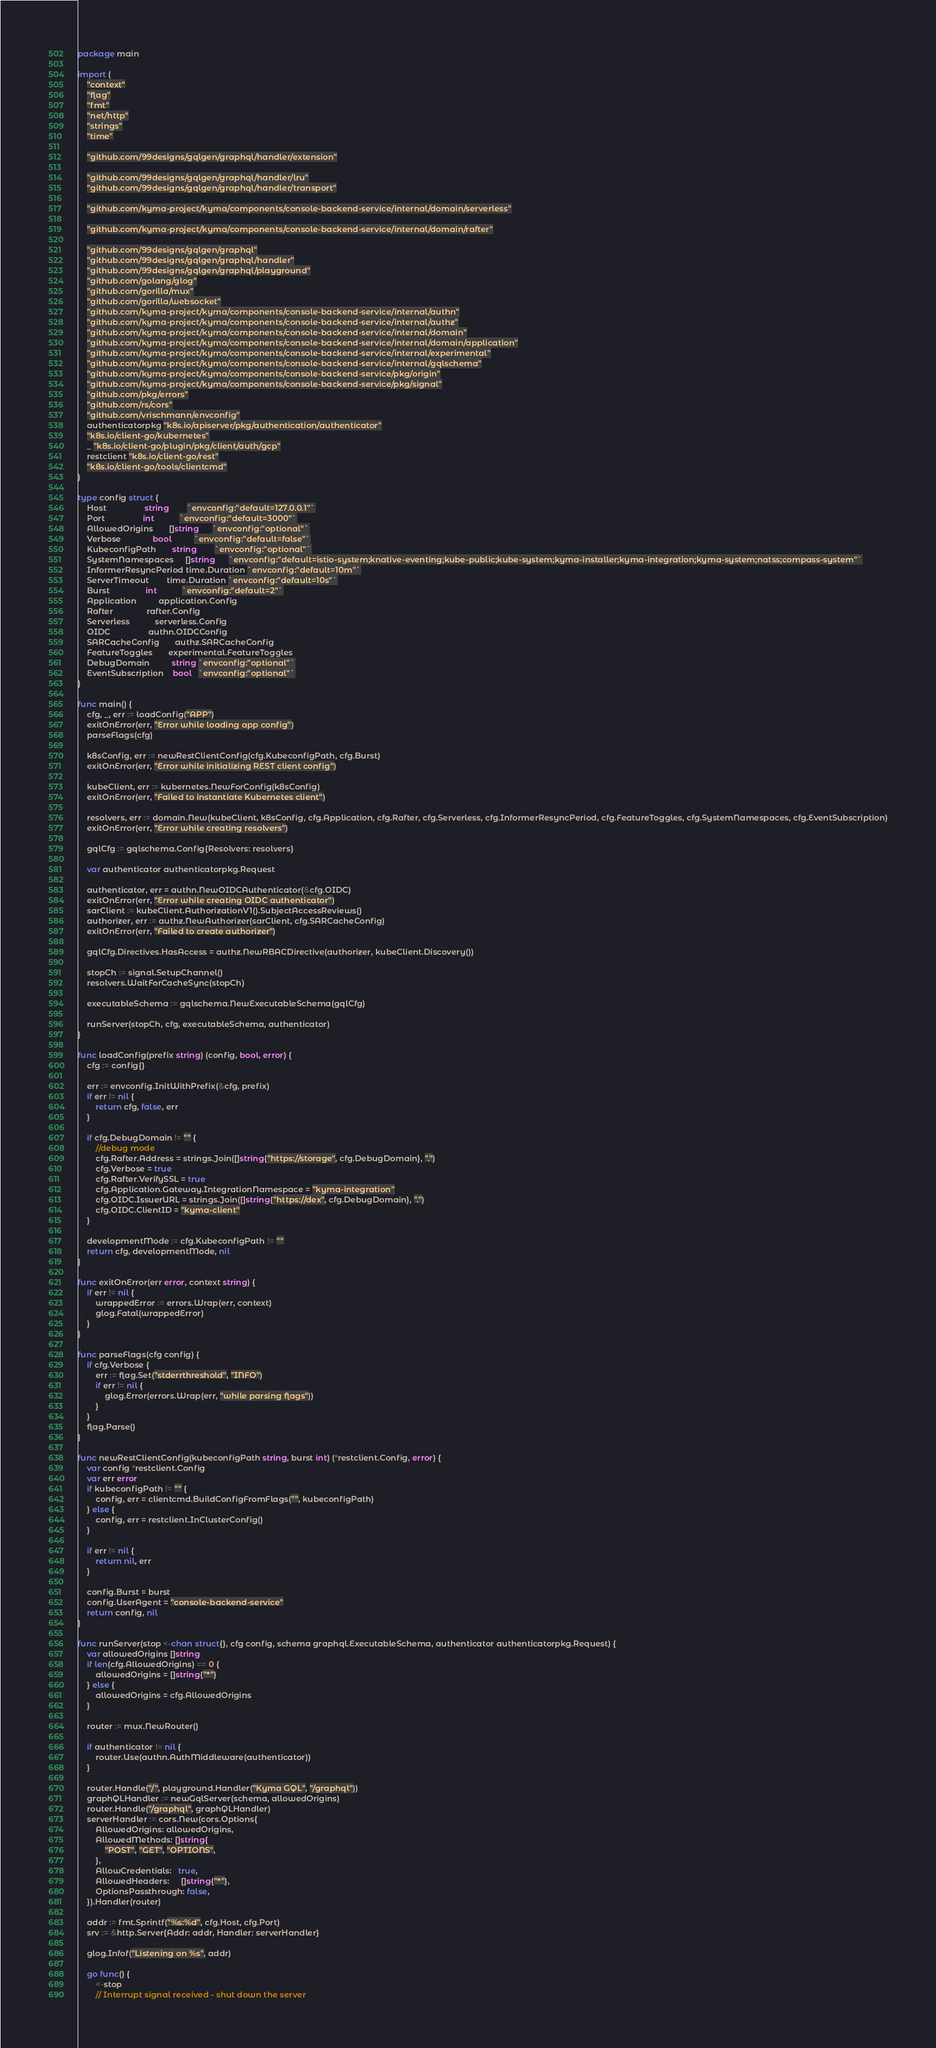Convert code to text. <code><loc_0><loc_0><loc_500><loc_500><_Go_>package main

import (
	"context"
	"flag"
	"fmt"
	"net/http"
	"strings"
	"time"

	"github.com/99designs/gqlgen/graphql/handler/extension"

	"github.com/99designs/gqlgen/graphql/handler/lru"
	"github.com/99designs/gqlgen/graphql/handler/transport"

	"github.com/kyma-project/kyma/components/console-backend-service/internal/domain/serverless"

	"github.com/kyma-project/kyma/components/console-backend-service/internal/domain/rafter"

	"github.com/99designs/gqlgen/graphql"
	"github.com/99designs/gqlgen/graphql/handler"
	"github.com/99designs/gqlgen/graphql/playground"
	"github.com/golang/glog"
	"github.com/gorilla/mux"
	"github.com/gorilla/websocket"
	"github.com/kyma-project/kyma/components/console-backend-service/internal/authn"
	"github.com/kyma-project/kyma/components/console-backend-service/internal/authz"
	"github.com/kyma-project/kyma/components/console-backend-service/internal/domain"
	"github.com/kyma-project/kyma/components/console-backend-service/internal/domain/application"
	"github.com/kyma-project/kyma/components/console-backend-service/internal/experimental"
	"github.com/kyma-project/kyma/components/console-backend-service/internal/gqlschema"
	"github.com/kyma-project/kyma/components/console-backend-service/pkg/origin"
	"github.com/kyma-project/kyma/components/console-backend-service/pkg/signal"
	"github.com/pkg/errors"
	"github.com/rs/cors"
	"github.com/vrischmann/envconfig"
	authenticatorpkg "k8s.io/apiserver/pkg/authentication/authenticator"
	"k8s.io/client-go/kubernetes"
	_ "k8s.io/client-go/plugin/pkg/client/auth/gcp"
	restclient "k8s.io/client-go/rest"
	"k8s.io/client-go/tools/clientcmd"
)

type config struct {
	Host                 string        `envconfig:"default=127.0.0.1"`
	Port                 int           `envconfig:"default=3000"`
	AllowedOrigins       []string      `envconfig:"optional"`
	Verbose              bool          `envconfig:"default=false"`
	KubeconfigPath       string        `envconfig:"optional"`
	SystemNamespaces     []string      `envconfig:"default=istio-system;knative-eventing;kube-public;kube-system;kyma-installer;kyma-integration;kyma-system;natss;compass-system"`
	InformerResyncPeriod time.Duration `envconfig:"default=10m"`
	ServerTimeout        time.Duration `envconfig:"default=10s"`
	Burst                int           `envconfig:"default=2"`
	Application          application.Config
	Rafter               rafter.Config
	Serverless           serverless.Config
	OIDC                 authn.OIDCConfig
	SARCacheConfig       authz.SARCacheConfig
	FeatureToggles       experimental.FeatureToggles
	DebugDomain          string `envconfig:"optional"`
	EventSubscription    bool   `envconfig:"optional"`
}

func main() {
	cfg, _, err := loadConfig("APP")
	exitOnError(err, "Error while loading app config")
	parseFlags(cfg)

	k8sConfig, err := newRestClientConfig(cfg.KubeconfigPath, cfg.Burst)
	exitOnError(err, "Error while initializing REST client config")

	kubeClient, err := kubernetes.NewForConfig(k8sConfig)
	exitOnError(err, "Failed to instantiate Kubernetes client")

	resolvers, err := domain.New(kubeClient, k8sConfig, cfg.Application, cfg.Rafter, cfg.Serverless, cfg.InformerResyncPeriod, cfg.FeatureToggles, cfg.SystemNamespaces, cfg.EventSubscription)
	exitOnError(err, "Error while creating resolvers")

	gqlCfg := gqlschema.Config{Resolvers: resolvers}

	var authenticator authenticatorpkg.Request

	authenticator, err = authn.NewOIDCAuthenticator(&cfg.OIDC)
	exitOnError(err, "Error while creating OIDC authenticator")
	sarClient := kubeClient.AuthorizationV1().SubjectAccessReviews()
	authorizer, err := authz.NewAuthorizer(sarClient, cfg.SARCacheConfig)
	exitOnError(err, "Failed to create authorizer")

	gqlCfg.Directives.HasAccess = authz.NewRBACDirective(authorizer, kubeClient.Discovery())

	stopCh := signal.SetupChannel()
	resolvers.WaitForCacheSync(stopCh)

	executableSchema := gqlschema.NewExecutableSchema(gqlCfg)

	runServer(stopCh, cfg, executableSchema, authenticator)
}

func loadConfig(prefix string) (config, bool, error) {
	cfg := config{}

	err := envconfig.InitWithPrefix(&cfg, prefix)
	if err != nil {
		return cfg, false, err
	}

	if cfg.DebugDomain != "" {
		//debug mode
		cfg.Rafter.Address = strings.Join([]string{"https://storage", cfg.DebugDomain}, ".")
		cfg.Verbose = true
		cfg.Rafter.VerifySSL = true
		cfg.Application.Gateway.IntegrationNamespace = "kyma-integration"
		cfg.OIDC.IssuerURL = strings.Join([]string{"https://dex", cfg.DebugDomain}, ".")
		cfg.OIDC.ClientID = "kyma-client"
	}

	developmentMode := cfg.KubeconfigPath != ""
	return cfg, developmentMode, nil
}

func exitOnError(err error, context string) {
	if err != nil {
		wrappedError := errors.Wrap(err, context)
		glog.Fatal(wrappedError)
	}
}

func parseFlags(cfg config) {
	if cfg.Verbose {
		err := flag.Set("stderrthreshold", "INFO")
		if err != nil {
			glog.Error(errors.Wrap(err, "while parsing flags"))
		}
	}
	flag.Parse()
}

func newRestClientConfig(kubeconfigPath string, burst int) (*restclient.Config, error) {
	var config *restclient.Config
	var err error
	if kubeconfigPath != "" {
		config, err = clientcmd.BuildConfigFromFlags("", kubeconfigPath)
	} else {
		config, err = restclient.InClusterConfig()
	}

	if err != nil {
		return nil, err
	}

	config.Burst = burst
	config.UserAgent = "console-backend-service"
	return config, nil
}

func runServer(stop <-chan struct{}, cfg config, schema graphql.ExecutableSchema, authenticator authenticatorpkg.Request) {
	var allowedOrigins []string
	if len(cfg.AllowedOrigins) == 0 {
		allowedOrigins = []string{"*"}
	} else {
		allowedOrigins = cfg.AllowedOrigins
	}

	router := mux.NewRouter()

	if authenticator != nil {
		router.Use(authn.AuthMiddleware(authenticator))
	}

	router.Handle("/", playground.Handler("Kyma GQL", "/graphql"))
	graphQLHandler := newGqlServer(schema, allowedOrigins)
	router.Handle("/graphql", graphQLHandler)
	serverHandler := cors.New(cors.Options{
		AllowedOrigins: allowedOrigins,
		AllowedMethods: []string{
			"POST", "GET", "OPTIONS",
		},
		AllowCredentials:   true,
		AllowedHeaders:     []string{"*"},
		OptionsPassthrough: false,
	}).Handler(router)

	addr := fmt.Sprintf("%s:%d", cfg.Host, cfg.Port)
	srv := &http.Server{Addr: addr, Handler: serverHandler}

	glog.Infof("Listening on %s", addr)

	go func() {
		<-stop
		// Interrupt signal received - shut down the server</code> 